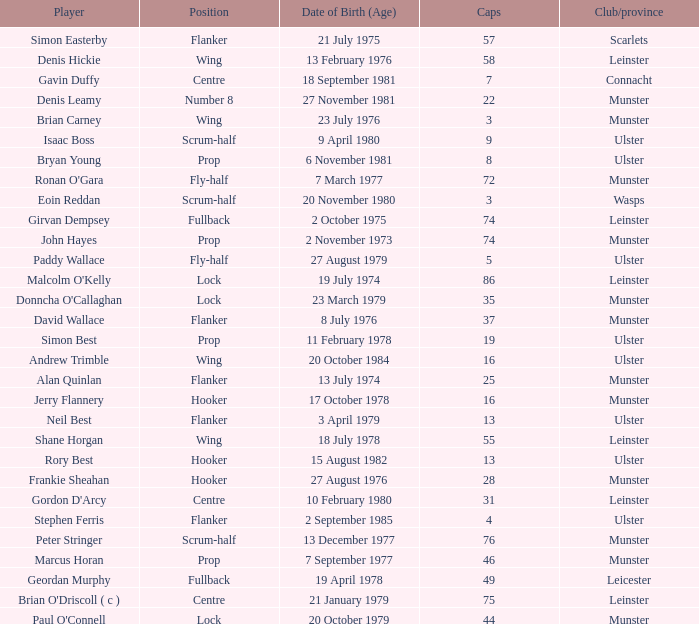Which player Munster from Munster is a fly-half? Ronan O'Gara. 